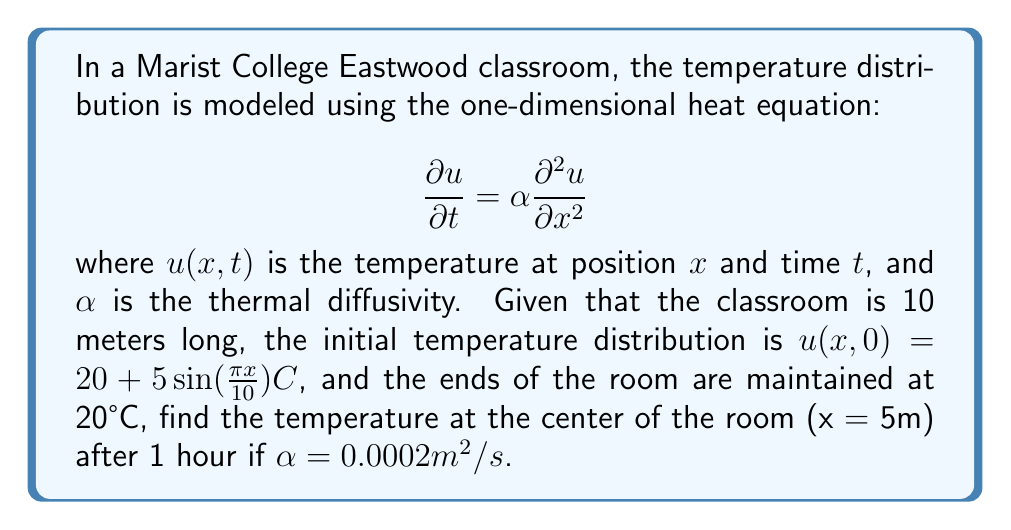What is the answer to this math problem? To solve this problem, we'll use the method of separation of variables:

1) The general solution for the heat equation with these boundary conditions is:

   $$u(x,t) = 20 + \sum_{n=1}^{\infty} B_n \sin(\frac{n\pi x}{L})e^{-\alpha(\frac{n\pi}{L})^2t}$$

   where $L = 10m$ is the length of the room.

2) We need to find $B_n$ using the initial condition:

   $$20 + 5\sin(\frac{\pi x}{10}) = 20 + \sum_{n=1}^{\infty} B_n \sin(\frac{n\pi x}{10})$$

3) Comparing coefficients, we see that $B_1 = 5$ and all other $B_n = 0$.

4) Therefore, our solution simplifies to:

   $$u(x,t) = 20 + 5\sin(\frac{\pi x}{10})e^{-\alpha(\frac{\pi}{10})^2t}$$

5) At the center of the room, $x = 5m$. After 1 hour, $t = 3600s$. Substituting these values:

   $$u(5,3600) = 20 + 5\sin(\frac{\pi \cdot 5}{10})e^{-0.0002(\frac{\pi}{10})^2 \cdot 3600}$$

6) Simplify:
   $$u(5,3600) = 20 + 5 \cdot e^{-0.0072\pi^2}$$

7) Calculate the final result:
   $$u(5,3600) \approx 20 + 5 \cdot 0.4895 \approx 22.45°C$$
Answer: 22.45°C 